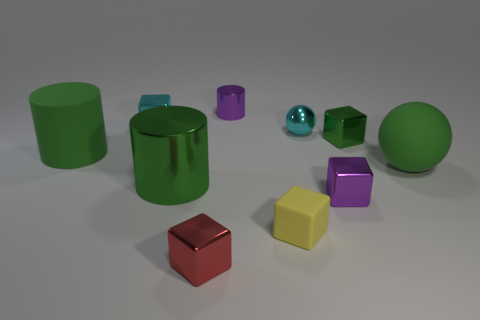Subtract all yellow spheres. How many green cylinders are left? 2 Subtract all green blocks. How many blocks are left? 4 Subtract all metal cylinders. How many cylinders are left? 1 Subtract 3 cubes. How many cubes are left? 2 Subtract all cyan cubes. Subtract all purple cylinders. How many cubes are left? 4 Subtract all balls. How many objects are left? 8 Subtract all small purple metal cubes. Subtract all tiny cyan metal blocks. How many objects are left? 8 Add 9 red metallic things. How many red metallic things are left? 10 Add 7 rubber cylinders. How many rubber cylinders exist? 8 Subtract 1 cyan balls. How many objects are left? 9 